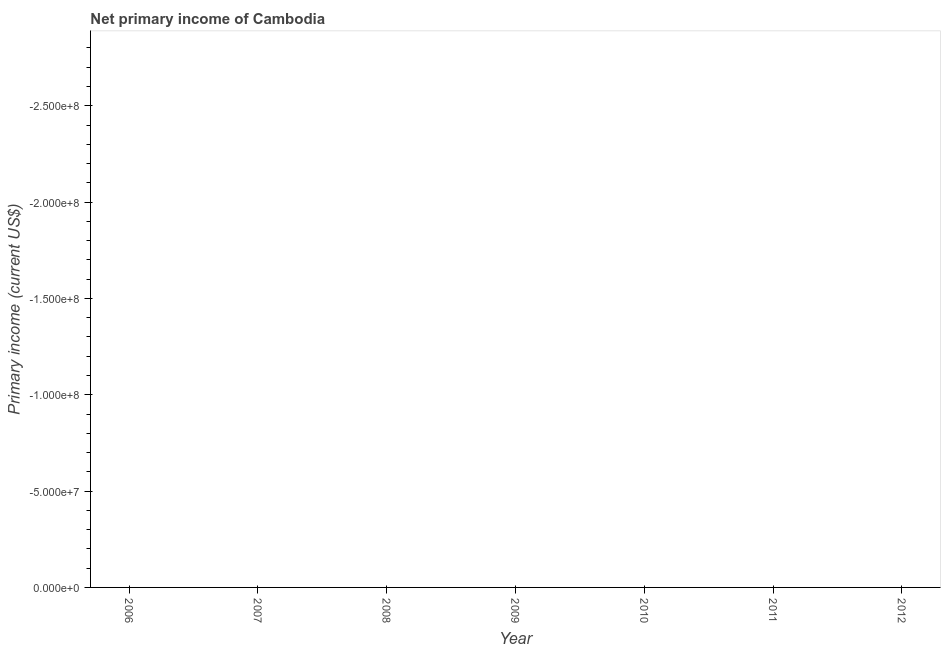Across all years, what is the minimum amount of primary income?
Offer a very short reply. 0. What is the median amount of primary income?
Provide a succinct answer. 0. In how many years, is the amount of primary income greater than the average amount of primary income taken over all years?
Your answer should be compact. 0. Does the amount of primary income monotonically increase over the years?
Provide a succinct answer. No. How many years are there in the graph?
Offer a very short reply. 7. What is the title of the graph?
Offer a terse response. Net primary income of Cambodia. What is the label or title of the Y-axis?
Offer a terse response. Primary income (current US$). What is the Primary income (current US$) in 2010?
Offer a terse response. 0. What is the Primary income (current US$) of 2011?
Offer a very short reply. 0. What is the Primary income (current US$) in 2012?
Provide a succinct answer. 0. 